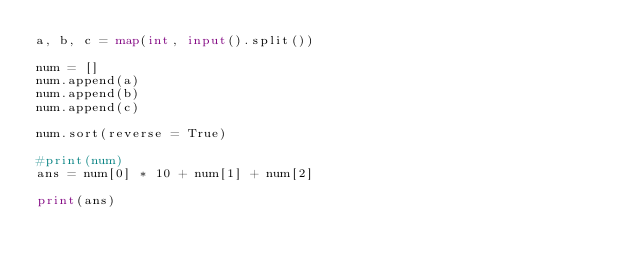Convert code to text. <code><loc_0><loc_0><loc_500><loc_500><_Python_>a, b, c = map(int, input().split())

num = []
num.append(a)
num.append(b)
num.append(c)

num.sort(reverse = True)

#print(num)
ans = num[0] * 10 + num[1] + num[2]

print(ans)
</code> 